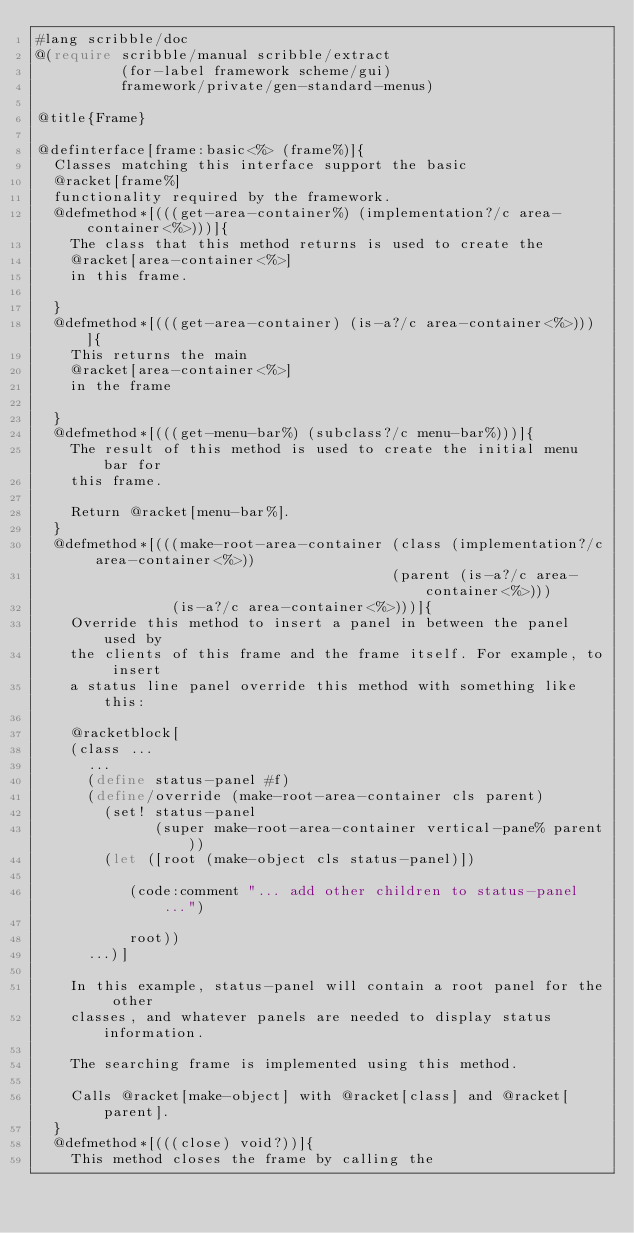<code> <loc_0><loc_0><loc_500><loc_500><_Racket_>#lang scribble/doc 
@(require scribble/manual scribble/extract
          (for-label framework scheme/gui)
          framework/private/gen-standard-menus)

@title{Frame}

@definterface[frame:basic<%> (frame%)]{
  Classes matching this interface support the basic 
  @racket[frame%]
  functionality required by the framework.
  @defmethod*[(((get-area-container%) (implementation?/c area-container<%>)))]{
    The class that this method returns is used to create the
    @racket[area-container<%>]
    in this frame.

  }
  @defmethod*[(((get-area-container) (is-a?/c area-container<%>)))]{
    This returns the main 
    @racket[area-container<%>]
    in the frame

  }
  @defmethod*[(((get-menu-bar%) (subclass?/c menu-bar%)))]{
    The result of this method is used to create the initial menu bar for
    this frame.

    Return @racket[menu-bar%].
  }
  @defmethod*[(((make-root-area-container (class (implementation?/c area-container<%>))
                                          (parent (is-a?/c area-container<%>)))
                (is-a?/c area-container<%>)))]{
    Override this method to insert a panel in between the panel used by
    the clients of this frame and the frame itself. For example, to insert
    a status line panel override this method with something like this:

    @racketblock[
    (class ...
      ...
      (define status-panel #f)
      (define/override (make-root-area-container cls parent)
        (set! status-panel
              (super make-root-area-container vertical-pane% parent))
        (let ([root (make-object cls status-panel)])

           (code:comment "... add other children to status-panel ...")

           root))
      ...)]

    In this example, status-panel will contain a root panel for the other
    classes, and whatever panels are needed to display status information.

    The searching frame is implemented using this method.

    Calls @racket[make-object] with @racket[class] and @racket[parent].
  }
  @defmethod*[(((close) void?))]{
    This method closes the frame by calling the</code> 